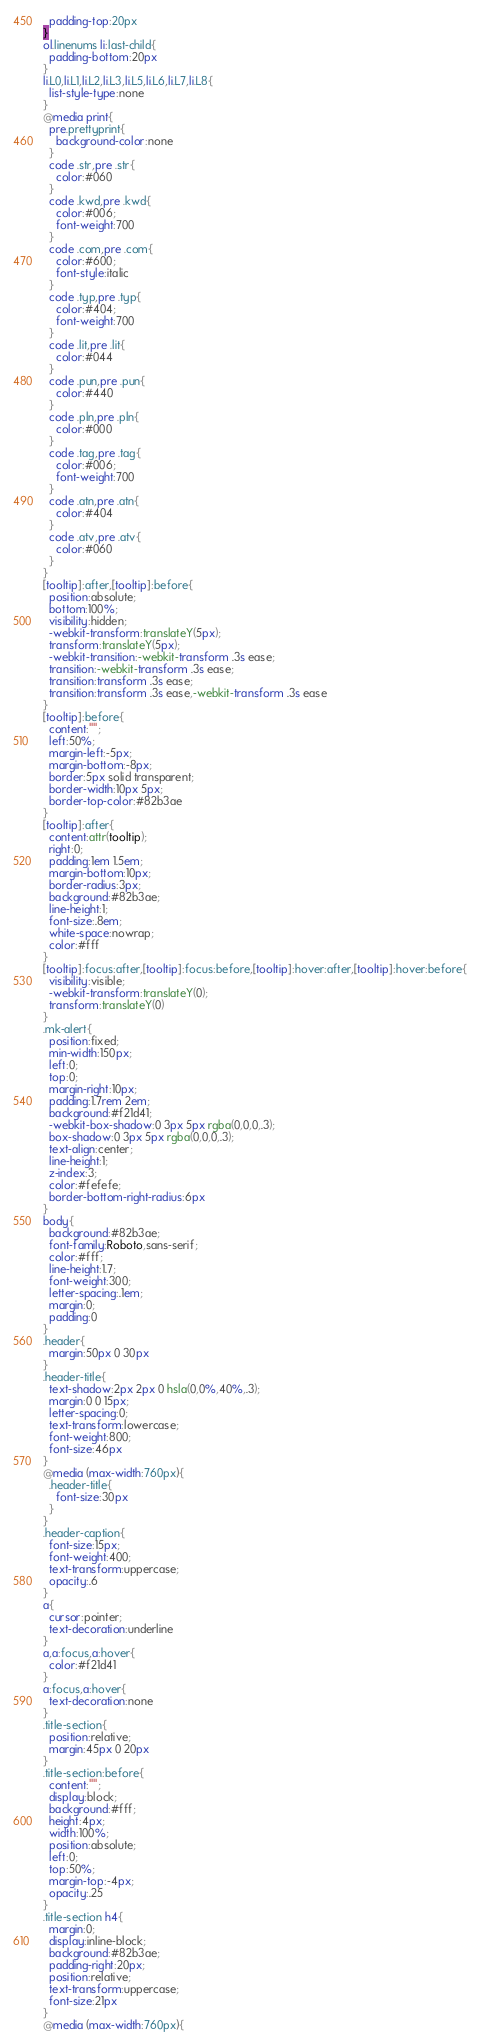<code> <loc_0><loc_0><loc_500><loc_500><_CSS_>  padding-top:20px
}
ol.linenums li:last-child{
  padding-bottom:20px
}
li.L0,li.L1,li.L2,li.L3,li.L5,li.L6,li.L7,li.L8{
  list-style-type:none
}
@media print{
  pre.prettyprint{
    background-color:none
  }
  code .str,pre .str{
    color:#060
  }
  code .kwd,pre .kwd{
    color:#006;
    font-weight:700
  }
  code .com,pre .com{
    color:#600;
    font-style:italic
  }
  code .typ,pre .typ{
    color:#404;
    font-weight:700
  }
  code .lit,pre .lit{
    color:#044
  }
  code .pun,pre .pun{
    color:#440
  }
  code .pln,pre .pln{
    color:#000
  }
  code .tag,pre .tag{
    color:#006;
    font-weight:700
  }
  code .atn,pre .atn{
    color:#404
  }
  code .atv,pre .atv{
    color:#060
  }
}
[tooltip]:after,[tooltip]:before{
  position:absolute;
  bottom:100%;
  visibility:hidden;
  -webkit-transform:translateY(5px);
  transform:translateY(5px);
  -webkit-transition:-webkit-transform .3s ease;
  transition:-webkit-transform .3s ease;
  transition:transform .3s ease;
  transition:transform .3s ease,-webkit-transform .3s ease
}
[tooltip]:before{
  content:"";
  left:50%;
  margin-left:-5px;
  margin-bottom:-8px;
  border:5px solid transparent;
  border-width:10px 5px;
  border-top-color:#82b3ae
}
[tooltip]:after{
  content:attr(tooltip);
  right:0;
  padding:1em 1.5em;
  margin-bottom:10px;
  border-radius:3px;
  background:#82b3ae;
  line-height:1;
  font-size:.8em;
  white-space:nowrap;
  color:#fff
}
[tooltip]:focus:after,[tooltip]:focus:before,[tooltip]:hover:after,[tooltip]:hover:before{
  visibility:visible;
  -webkit-transform:translateY(0);
  transform:translateY(0)
}
.mk-alert{
  position:fixed;
  min-width:150px;
  left:0;
  top:0;
  margin-right:10px;
  padding:1.7rem 2em;
  background:#f21d41;
  -webkit-box-shadow:0 3px 5px rgba(0,0,0,.3);
  box-shadow:0 3px 5px rgba(0,0,0,.3);
  text-align:center;
  line-height:1;
  z-index:3;
  color:#fefefe;
  border-bottom-right-radius:6px
}
body{
  background:#82b3ae;
  font-family:Roboto,sans-serif;
  color:#fff;
  line-height:1.7;
  font-weight:300;
  letter-spacing:.1em;
  margin:0;
  padding:0
}
.header{
  margin:50px 0 30px
}
.header-title{
  text-shadow:2px 2px 0 hsla(0,0%,40%,.3);
  margin:0 0 15px;
  letter-spacing:0;
  text-transform:lowercase;
  font-weight:800;
  font-size:46px
}
@media (max-width:760px){
  .header-title{
    font-size:30px
  }
}
.header-caption{
  font-size:15px;
  font-weight:400;
  text-transform:uppercase;
  opacity:.6
}
a{
  cursor:pointer;
  text-decoration:underline
}
a,a:focus,a:hover{
  color:#f21d41
}
a:focus,a:hover{
  text-decoration:none
}
.title-section{
  position:relative;
  margin:45px 0 20px
}
.title-section:before{
  content:"";
  display:block;
  background:#fff;
  height:4px;
  width:100%;
  position:absolute;
  left:0;
  top:50%;
  margin-top:-4px;
  opacity:.25
}
.title-section h4{
  margin:0;
  display:inline-block;
  background:#82b3ae;
  padding-right:20px;
  position:relative;
  text-transform:uppercase;
  font-size:21px
}
@media (max-width:760px){</code> 